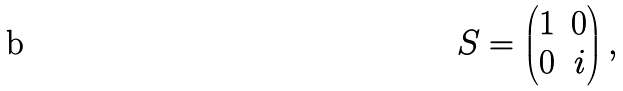Convert formula to latex. <formula><loc_0><loc_0><loc_500><loc_500>S = \begin{pmatrix} 1 & 0 \\ 0 & i \end{pmatrix} ,</formula> 